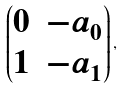Convert formula to latex. <formula><loc_0><loc_0><loc_500><loc_500>\begin{pmatrix} 0 & - a _ { 0 } \\ 1 & - a _ { 1 } \\ \end{pmatrix} ,</formula> 